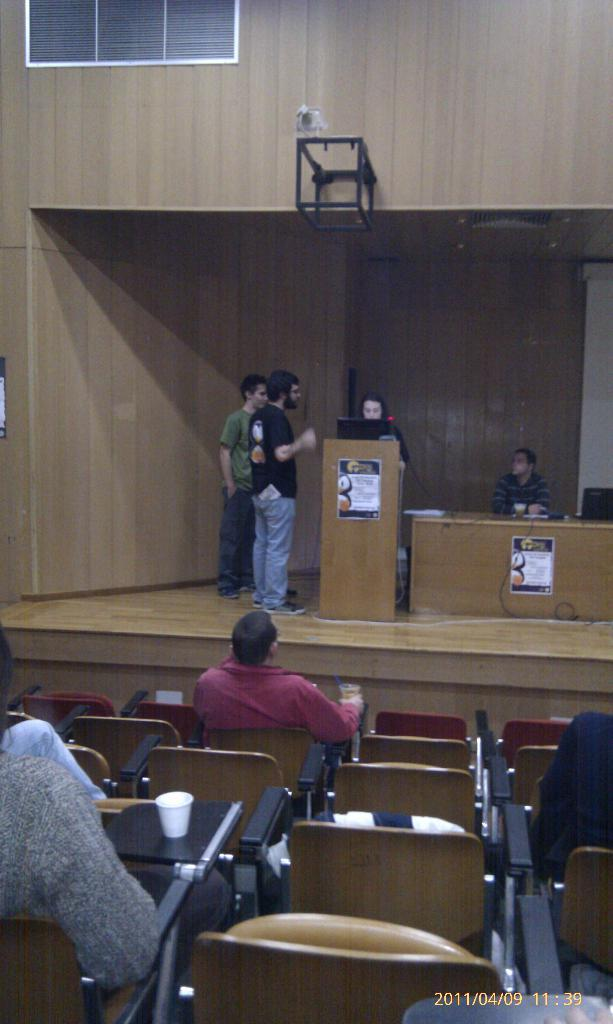What are the persons in the image doing? Some persons are sitting on chairs, while others are standing. What type of furniture is present in the image? Chairs and tables are visible in the image. What electronic device can be seen on a podium? A laptop is on a podium in the image. What can be seen in the background of the image? There is a wall and a window in the background. What type of scent can be detected in the image? There is no information about scents in the image, so it cannot be determined. How does the pollution affect the persons in the image? There is no mention of pollution in the image, so it cannot be determined how it might affect the persons. 